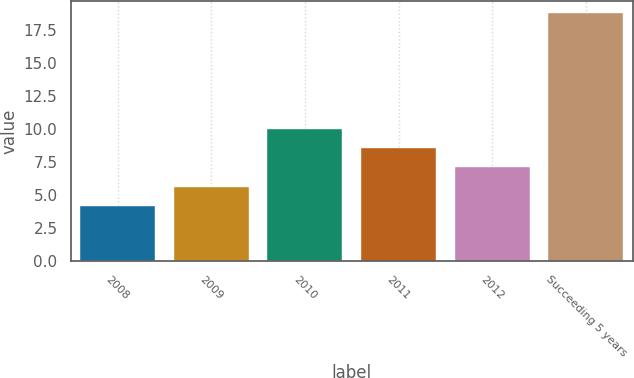<chart> <loc_0><loc_0><loc_500><loc_500><bar_chart><fcel>2008<fcel>2009<fcel>2010<fcel>2011<fcel>2012<fcel>Succeeding 5 years<nl><fcel>4.2<fcel>5.66<fcel>10.04<fcel>8.58<fcel>7.12<fcel>18.8<nl></chart> 